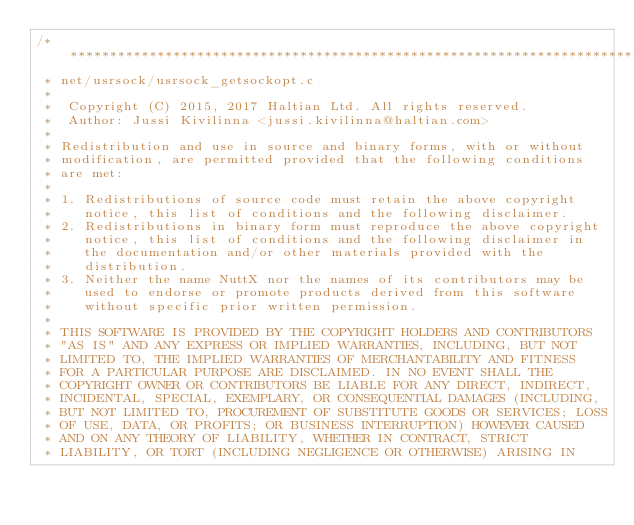<code> <loc_0><loc_0><loc_500><loc_500><_C_>/****************************************************************************
 * net/usrsock/usrsock_getsockopt.c
 *
 *  Copyright (C) 2015, 2017 Haltian Ltd. All rights reserved.
 *  Author: Jussi Kivilinna <jussi.kivilinna@haltian.com>
 *
 * Redistribution and use in source and binary forms, with or without
 * modification, are permitted provided that the following conditions
 * are met:
 *
 * 1. Redistributions of source code must retain the above copyright
 *    notice, this list of conditions and the following disclaimer.
 * 2. Redistributions in binary form must reproduce the above copyright
 *    notice, this list of conditions and the following disclaimer in
 *    the documentation and/or other materials provided with the
 *    distribution.
 * 3. Neither the name NuttX nor the names of its contributors may be
 *    used to endorse or promote products derived from this software
 *    without specific prior written permission.
 *
 * THIS SOFTWARE IS PROVIDED BY THE COPYRIGHT HOLDERS AND CONTRIBUTORS
 * "AS IS" AND ANY EXPRESS OR IMPLIED WARRANTIES, INCLUDING, BUT NOT
 * LIMITED TO, THE IMPLIED WARRANTIES OF MERCHANTABILITY AND FITNESS
 * FOR A PARTICULAR PURPOSE ARE DISCLAIMED. IN NO EVENT SHALL THE
 * COPYRIGHT OWNER OR CONTRIBUTORS BE LIABLE FOR ANY DIRECT, INDIRECT,
 * INCIDENTAL, SPECIAL, EXEMPLARY, OR CONSEQUENTIAL DAMAGES (INCLUDING,
 * BUT NOT LIMITED TO, PROCUREMENT OF SUBSTITUTE GOODS OR SERVICES; LOSS
 * OF USE, DATA, OR PROFITS; OR BUSINESS INTERRUPTION) HOWEVER CAUSED
 * AND ON ANY THEORY OF LIABILITY, WHETHER IN CONTRACT, STRICT
 * LIABILITY, OR TORT (INCLUDING NEGLIGENCE OR OTHERWISE) ARISING IN</code> 